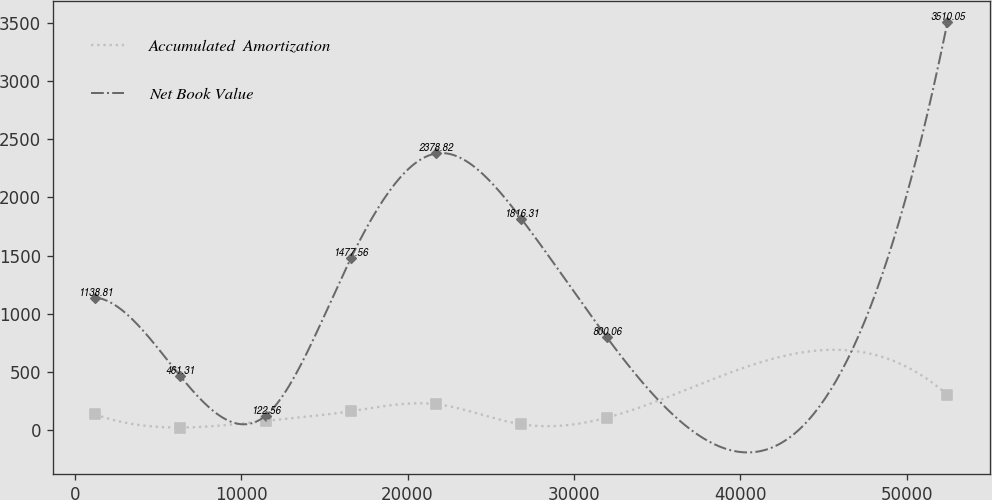<chart> <loc_0><loc_0><loc_500><loc_500><line_chart><ecel><fcel>Accumulated  Amortization<fcel>Net Book Value<nl><fcel>1225.21<fcel>132.71<fcel>1138.81<nl><fcel>6348.94<fcel>20.39<fcel>461.31<nl><fcel>11472.7<fcel>76.55<fcel>122.56<nl><fcel>16596.4<fcel>160.79<fcel>1477.56<nl><fcel>21720.1<fcel>220.91<fcel>2378.82<nl><fcel>26843.8<fcel>48.47<fcel>1816.31<nl><fcel>31967.6<fcel>104.63<fcel>800.06<nl><fcel>52462.5<fcel>301.18<fcel>3510.05<nl></chart> 